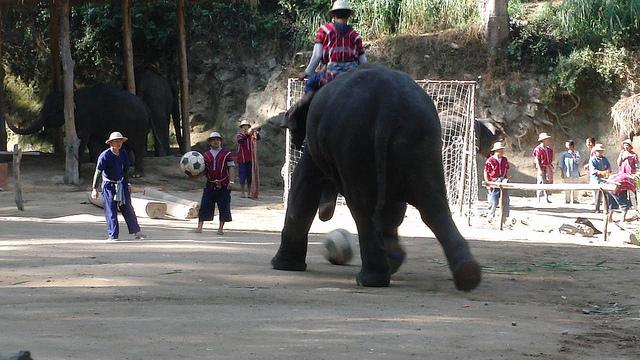What is this this elephant doing?

Choices:
A) drinking
B) painting
C) playing soccer
D) eating playing soccer 